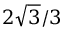<formula> <loc_0><loc_0><loc_500><loc_500>2 { \sqrt { 3 } } / 3</formula> 